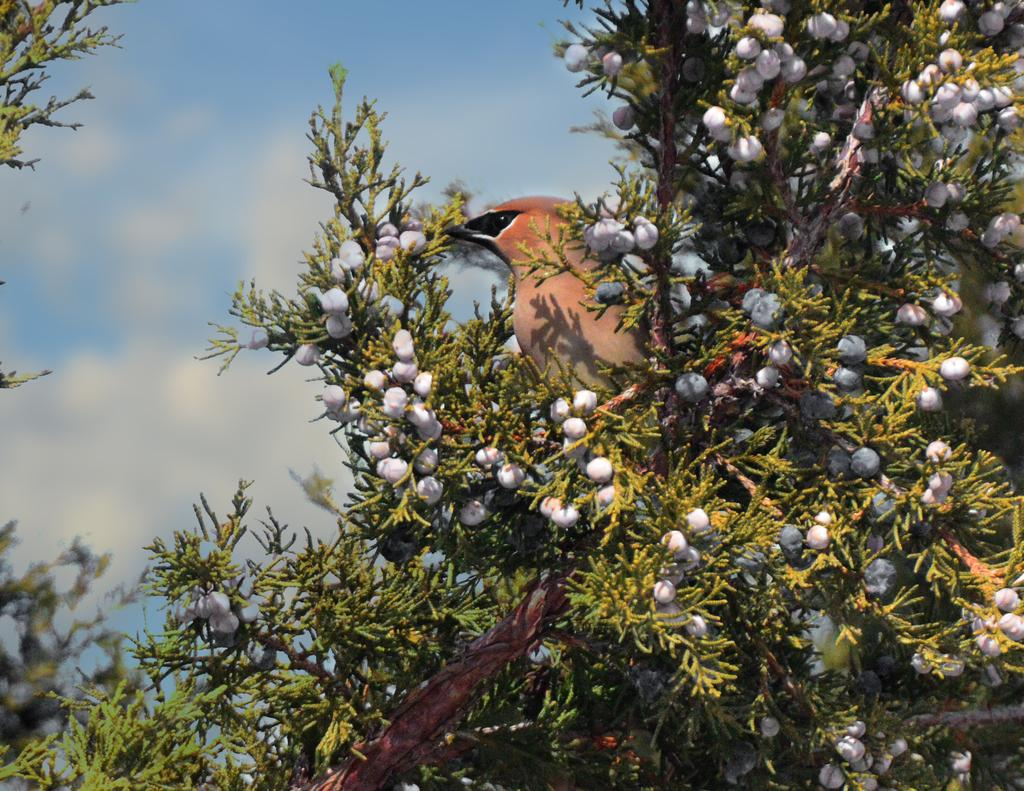What is located in the front of the image? There are plants in the front of the image. What is on top of the plants? A bird is standing on the plants. How would you describe the background of the image? The background of the image is blurry. What is the condition of the sky in the image? The sky is cloudy in the image. What type of objects can be seen on the plants? There are cotton-like objects on the plants. What decision does the bird make while standing on the plants in the image? There is no indication in the image that the bird is making a decision; it is simply standing on the plants. Is there a trail visible in the image? There is no trail present in the image. 